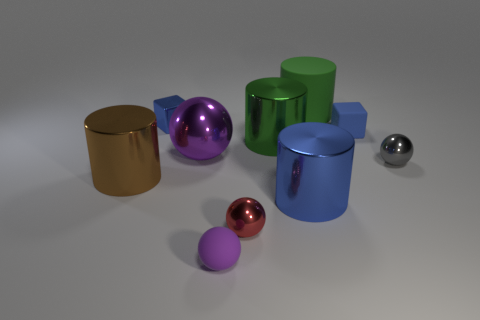Subtract all balls. How many objects are left? 6 Add 6 green things. How many green things are left? 8 Add 2 tiny balls. How many tiny balls exist? 5 Subtract 0 cyan cylinders. How many objects are left? 10 Subtract all small gray metallic things. Subtract all large green rubber objects. How many objects are left? 8 